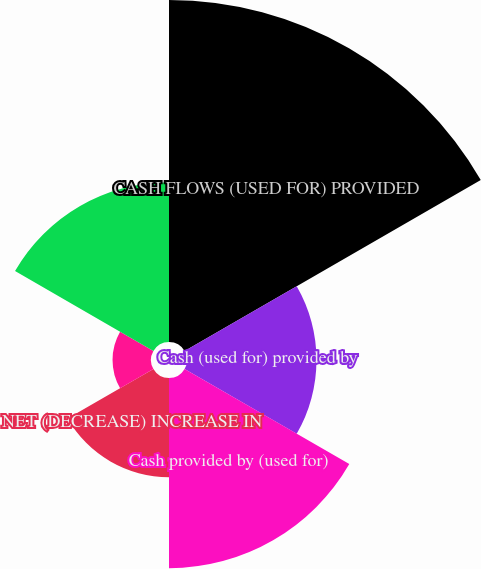<chart> <loc_0><loc_0><loc_500><loc_500><pie_chart><fcel>CASH FLOWS (USED FOR) PROVIDED<fcel>Cash (used for) provided by<fcel>Cash provided by (used for)<fcel>NET (DECREASE) INCREASE IN<fcel>CASH AND CASH EQUIVALENTS<fcel>Unnamed: 5<nl><fcel>35.66%<fcel>13.5%<fcel>19.83%<fcel>10.34%<fcel>4.01%<fcel>16.66%<nl></chart> 